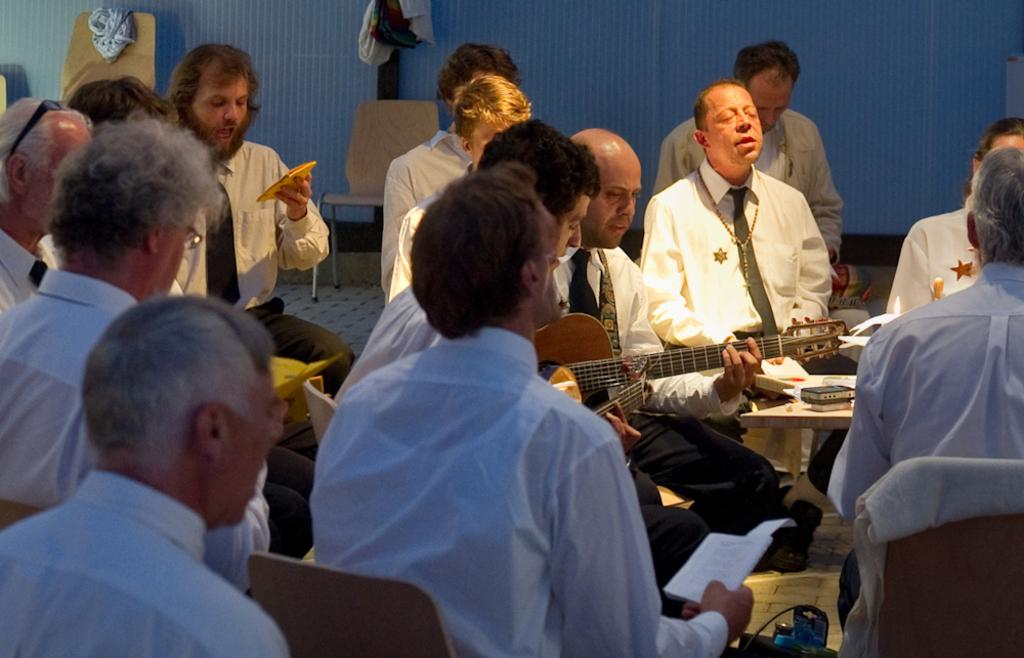What are the people in the image doing? The people in the image are praying. Can you describe the position of one of the people in the image? There is a person sitting on a chair. What is the person on the chair doing? The person on the chair is playing a guitar. What type of dirt can be seen on the floor in the image? There is no dirt visible on the floor in the image. Is there a fight happening between the people in the image? No, the people in the image are praying, not fighting. 